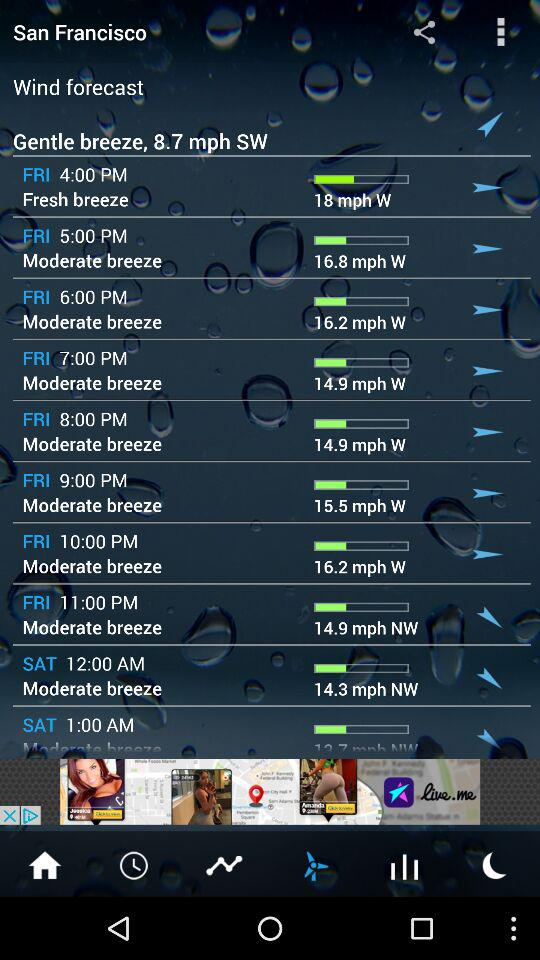What was the wind speed at 7 p.m. on Friday? The wind speed was 14.9 mph. 